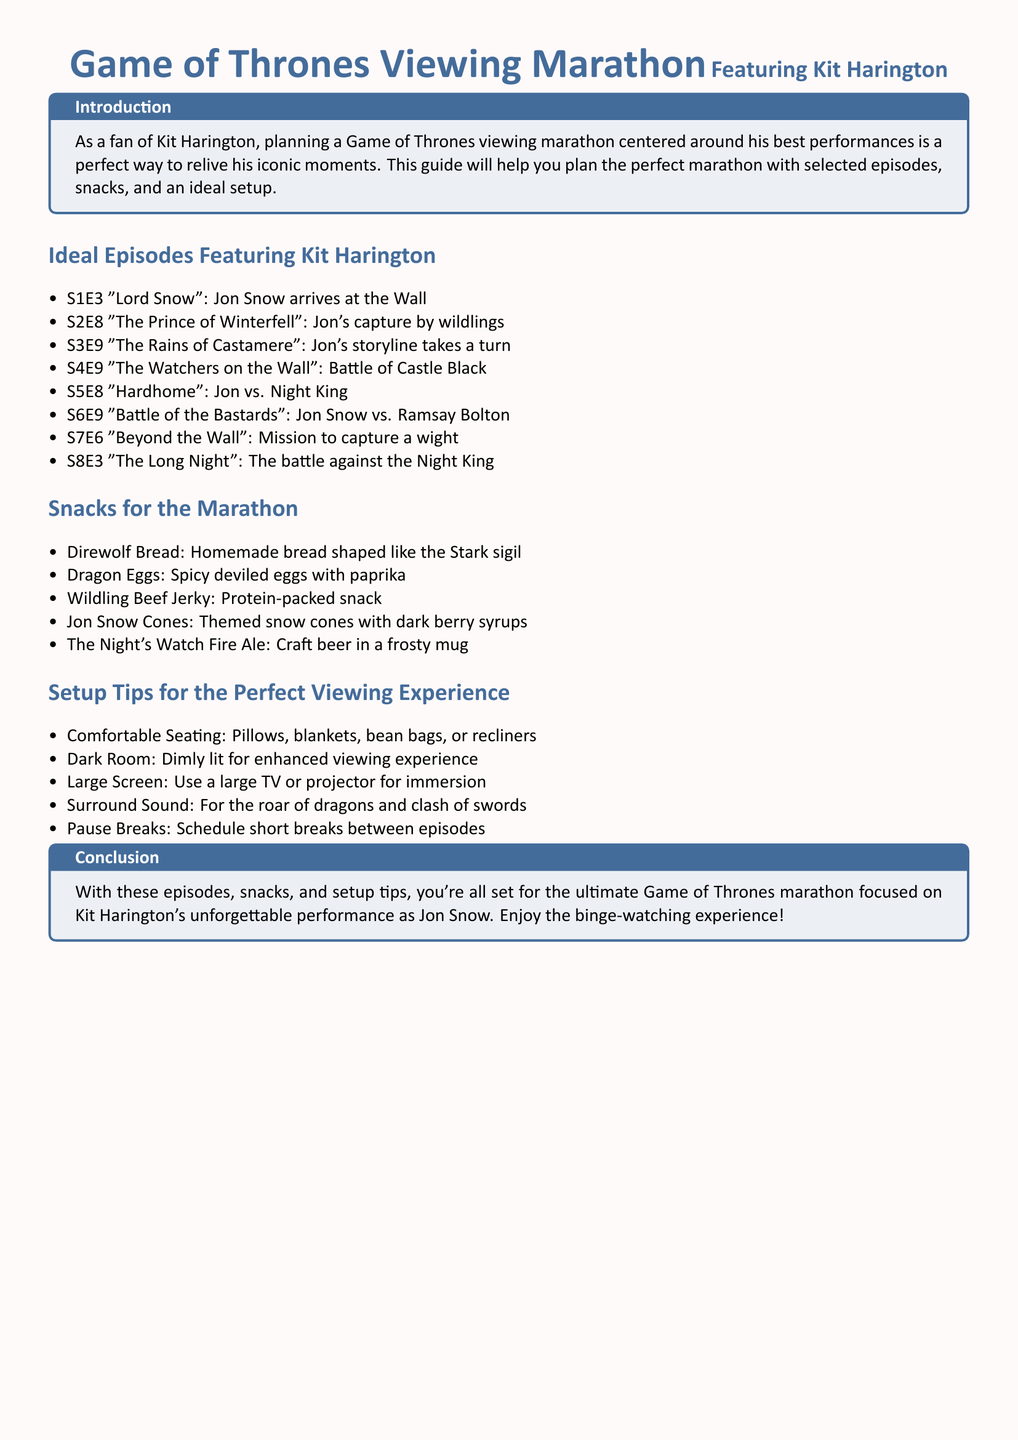What is the title of episode 3 in season 1? The document specifies that episode 3 of season 1 is titled "Lord Snow."
Answer: "Lord Snow" What snack is shaped like the Stark sigil? The guide mentions "Direwolf Bread" as being shaped like the Stark sigil.
Answer: Direwolf Bread Which episode features the Battle of the Bastards? According to the document, "Battle of the Bastards" occurs in season 6, episode 9.
Answer: S6E9 What is recommended for the viewing setup to enhance the experience? The document suggests using a “large TV or projector” for an immersive viewing experience.
Answer: Large screen How many ideal episodes featuring Kit Harington are listed? The total number of episodes featuring Kit Harington listed is eight.
Answer: 8 What type of themed snack is mentioned alongside dark berry syrups? The guide refers to “Jon Snow Cones” as the themed snack with dark berry syrups.
Answer: Jon Snow Cones What should the room be like for the viewing experience? The guide advises to have a “dark room” for enhanced viewing experience.
Answer: Dark Room 